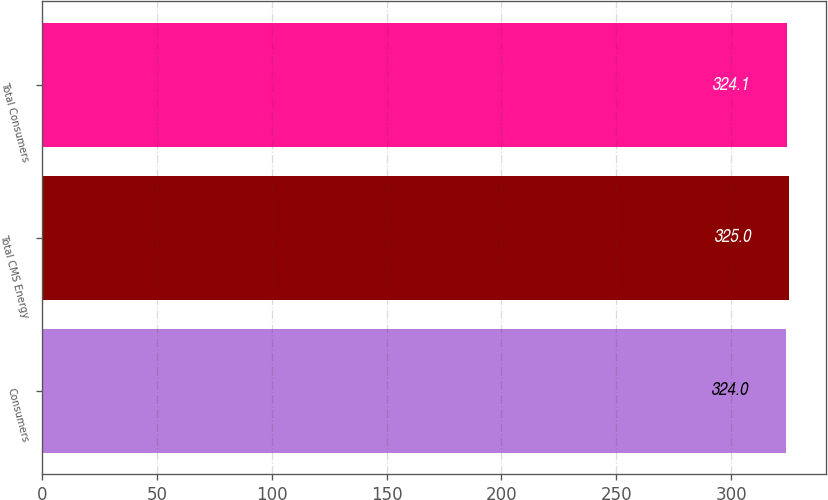Convert chart. <chart><loc_0><loc_0><loc_500><loc_500><bar_chart><fcel>Consumers<fcel>Total CMS Energy<fcel>Total Consumers<nl><fcel>324<fcel>325<fcel>324.1<nl></chart> 